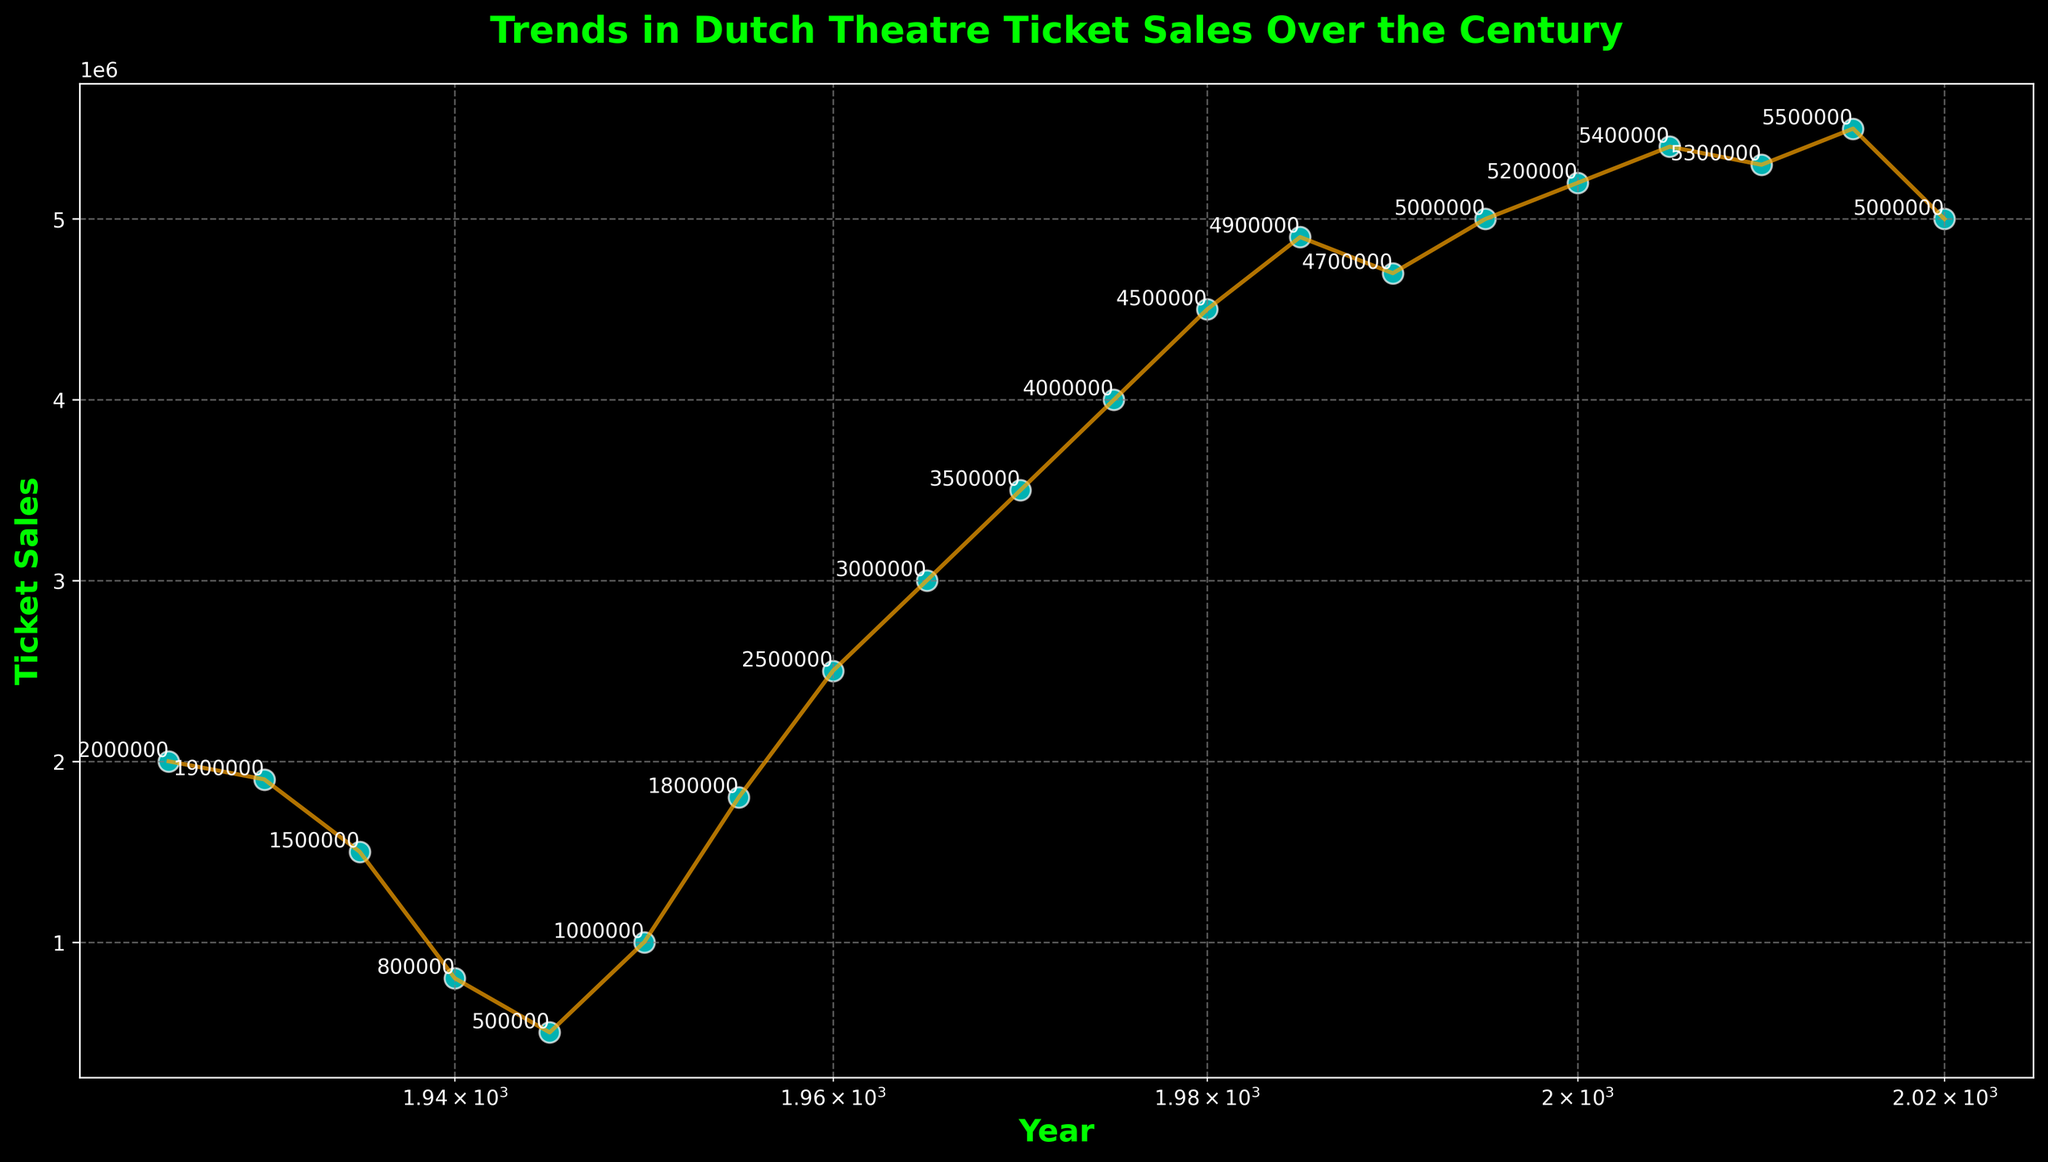What was the general trend in ticket sales between 1940 and 1960? Between 1940 and 1960, ticket sales increased significantly. They were as low as 500,000 in 1945 and rose to 2,500,000 by 1960. This marks a clear upward trend over these two decades.
Answer: An increasing trend Which year had the highest ticket sales? To find the year with the highest ticket sales, look at the y-values and find the corresponding year when the ticket sales peaked. The highest value on the y-axis is 5,500,000 in the year 2015.
Answer: 2015 How did ticket sales change during World War II (1940-1945)? Ticket sales decreased dramatically during World War II. They fell from 800,000 in 1940 to 500,000 in 1945, likely due to the war's impact.
Answer: Decreased Compare the ticket sales in 1930 and 1950. Which year had higher sales and by how much? First, locate the ticket sales for 1930 (1,900,000) and 1950 (1,000,000). Compare the two by subtracting the smaller number from the larger. 1,900,000 - 1,000,000 = 900,000. Therefore, 1930 had 900,000 more ticket sales than 1950.
Answer: 1930 by 900,000 What was the percentage decrease in ticket sales from 1935 to 1945? To calculate the percentage decrease: ((1,500,000 - 500,000) / 1,500,000) * 100. The difference in sales is 1,000,000, then divide by the original value (1,500,000) and multiply by 100.
Answer: 66.67% Between which consecutive decades did ticket sales see the smallest increase? Evaluating the differences between decades (1925-1935, 1935-1945, etc.), the smallest increase happened between 1980 (4,500,000) and 1990 (4,700,000). The increase here is only 200,000.
Answer: 1980-1990 What was the approximate rate of change in ticket sales from 1925 to 2020? The overall change is from 2,000,000 in 1925 to 5,000,000 in 2020. The total change is 3,000,000 over 95 years. The average rate of change is 3,000,000 / 95 years.
Answer: Approximately 31,579 per year How do the visual attributes like color and line style differentiate between different years and trends? The scatter plot uses cyan-colored dots with white edges to mark each year. An orange line connecting these points helps visualize the trend. These visual cues make it easier to follow the changes over the years.
Answer: Cyan dots and an orange line What was the impact of economic downturns in the 20th century on ticket sales? The Great Depression (1930s) and World War II (1940s) caused dramatic decreases in ticket sales. Specifically, ticket sales dropped from 1,900,000 in 1930 to 1,500,000 in 1935, and from 800,000 in 1940 to 500,000 in 1945.
Answer: Significant decrease 